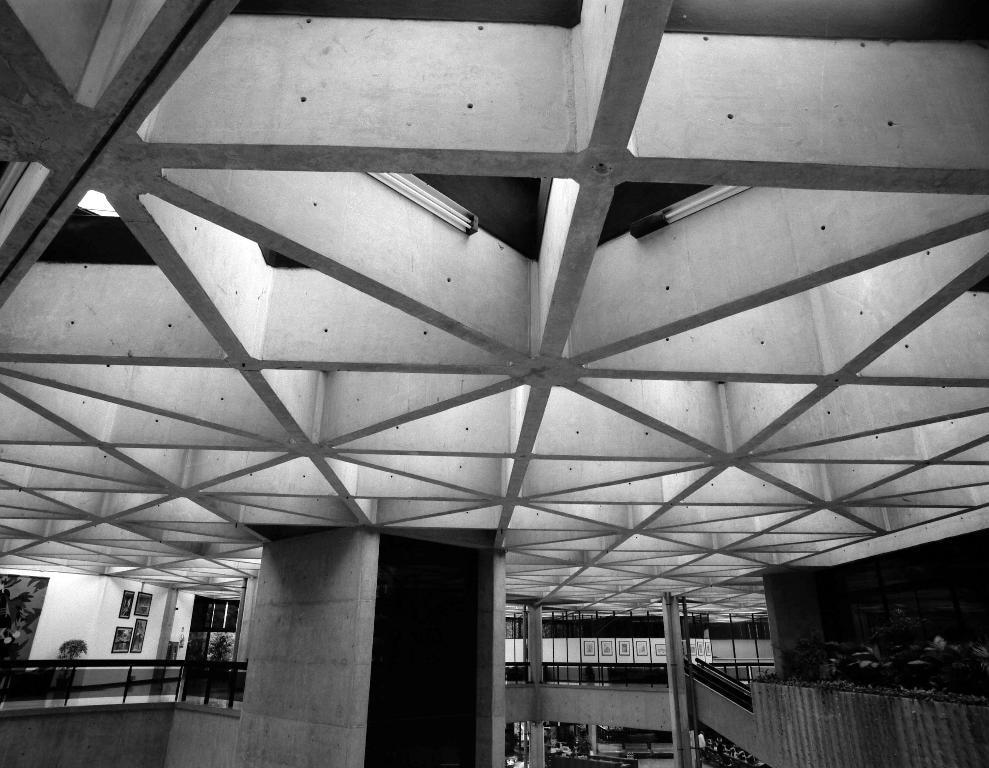Please provide a concise description of this image. This image is taken inside the building. In this image there are stairs and we can see frames on the wall. At the top there are lights and we can see railings. 